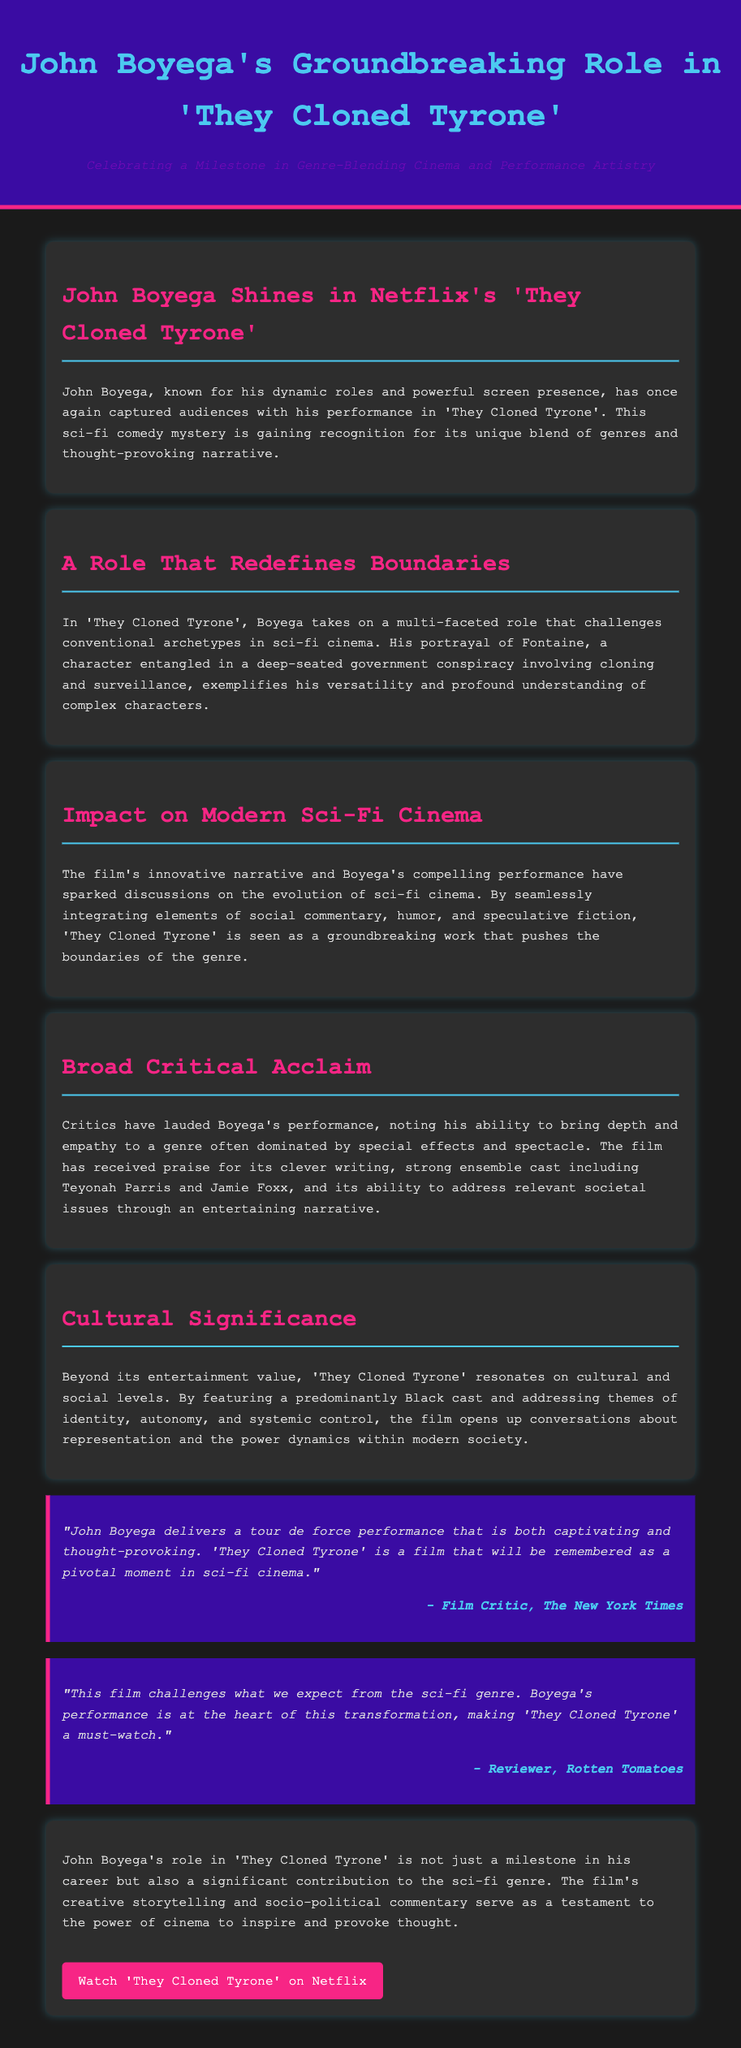What is the title of the film? The title of the film in the press release is stated clearly in the header and throughout the content.
Answer: They Cloned Tyrone Who plays the character Fontaine? The document identifies John Boyega as the actor portraying the character Fontaine.
Answer: John Boyega What genre does 'They Cloned Tyrone' belong to? The press release categorizes the film as a sci-fi comedy mystery, which is indicated in the opening sections.
Answer: Sci-fi comedy mystery Which two other actors are mentioned in the film alongside John Boyega? The document mentions Teyonah Parris and Jamie Foxx as part of the strong ensemble cast.
Answer: Teyonah Parris and Jamie Foxx How is Boyega's performance described by The New York Times? The quote from The New York Times highlights Boyega's performance as captivating and thought-provoking, showcasing the critical acclaim he received.
Answer: Captivating and thought-provoking What themes does 'They Cloned Tyrone' address? The document lists themes such as identity, autonomy, and systemic control, representing significant issues explored in the film.
Answer: Identity, autonomy, and systemic control What impact does the film have on modern sci-fi cinema? The press release discusses the film's innovative narrative and critical discussions surrounding the evolution of the genre due to its unique blend of elements.
Answer: Innovative narrative How is the film's caste described in terms of cultural representation? The press release emphasizes that the film features a predominantly Black cast, which speaks to its cultural significance.
Answer: Predominantly Black cast What overall contribution does Boyega's role make to the sci-fi genre? The closing remarks in the document claim that Boyega's role is a significant contribution to both his career and the sci-fi genre overall.
Answer: Significant contribution to the sci-fi genre 